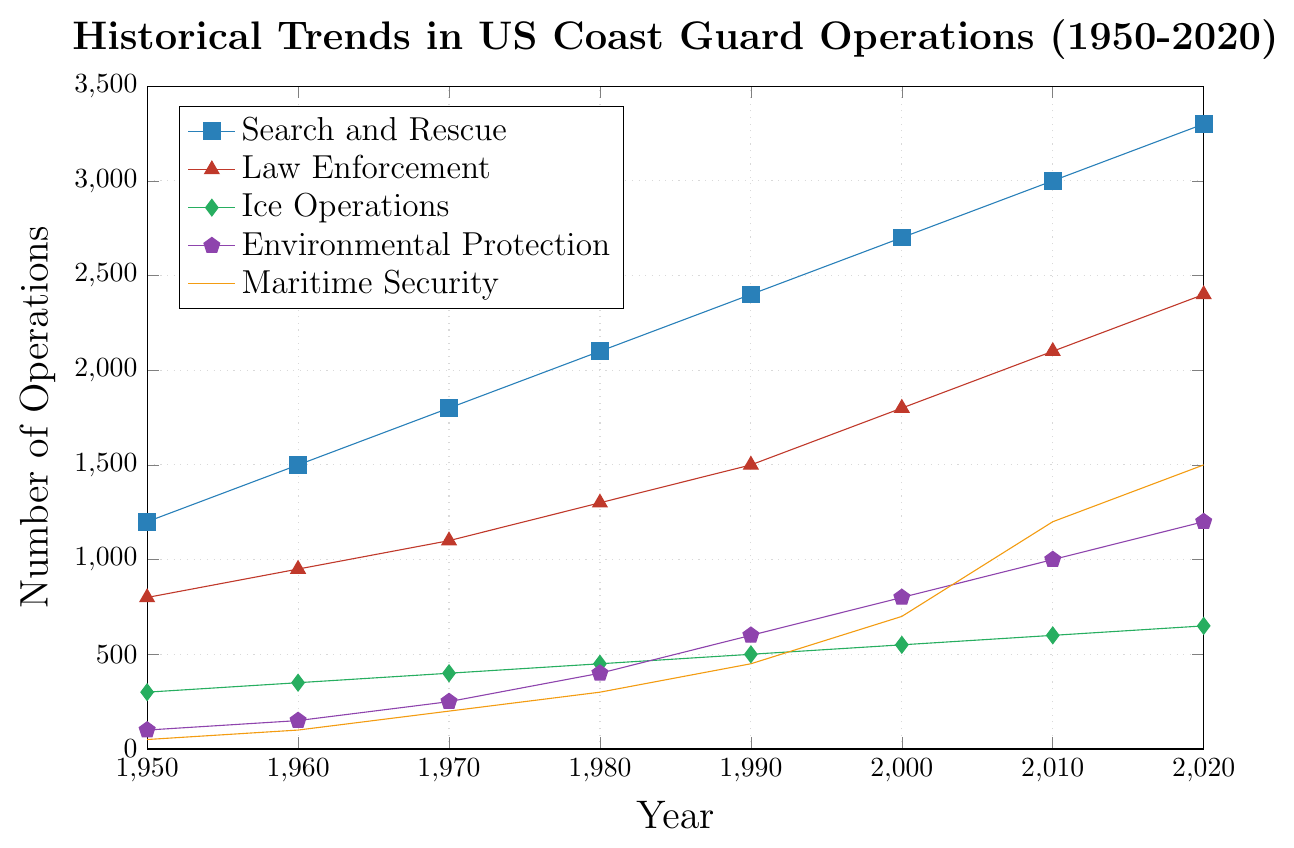What type of operation had the highest number of operations in 2020? To find the operation with the highest number in 2020, locate the data points for 2020 for each operation type. The highest value corresponds to "Search and Rescue" with 3300 operations.
Answer: Search and Rescue How many more operations did "Environmental Protection" have in 2020 compared to 1980? Identify the number of "Environmental Protection" operations in 2020 (1200) and in 1980 (400). Subtract the 1980 value from the 2020 value: 1200 - 400 = 800.
Answer: 800 Which operation type showed the greatest increase in number of operations from 1950 to 2020? Calculate the increase for each operation by subtracting the 1950 value from the 2020 value: "Search and Rescue" (3300-1200 = 2100), "Law Enforcement" (2400-800 = 1600), "Ice Operations" (650-300 = 350), "Environmental Protection" (1200-100 = 1100), and "Maritime Security" (1500-50 = 1450). The largest increase is in "Search and Rescue" with 2100 additional operations.
Answer: Search and Rescue Which two operation types had the same number of operations in 2010? Locate the data points for each operation type in 2010. "Environmental Protection" and "Maritime Security" both have 1200 operations in 2010.
Answer: Environmental Protection and Maritime Security What was the trend in the number of "Law Enforcement" operations between 1950 and 2020? To understand the trend, observe the data points for "Law Enforcement" from 1950 (800) to 2020 (2400). The values show a continuous increasing trend across these years.
Answer: Increasing By how much did "Ice Operations" operations increase on average per decade from 1950 to 2020? To find the average increase per decade, first find the total increase from 1950 (300) to 2020 (650), which is 650 - 300 = 350. Then divide this by the number of decades (7): 350 / 7 = 50.
Answer: 50 Which year saw "Environmental Protection" operations surpass 500 operations for the first time? Look for the first year where "Environmental Protection" operations exceed 500. In 1990, the value was 600. Before 1990, the values were below 500.
Answer: 1990 Compare the number of operations for "Maritime Security" and "Ice Operations" in 2000. Which was higher and by how much? Locate the values for both in 2000: "Maritime Security" had 700 operations, and "Ice Operations" had 550. The difference is 700 - 550 = 150, with "Maritime Security" higher.
Answer: Maritime Security, 150 What color is used to represent "Search and Rescue" operations in the figure? Identify the color associated with "Search and Rescue" based on the legend provided. The color used is blue.
Answer: Blue Between 1950 and 2020, which operation type had the most stable (least fluctuating) number of operations? Compare the range of values for each operation type. "Ice Operations" values range from 300 in 1950 to 650 in 2020, showing the least fluctuation or change compared to other operations.
Answer: Ice Operations 